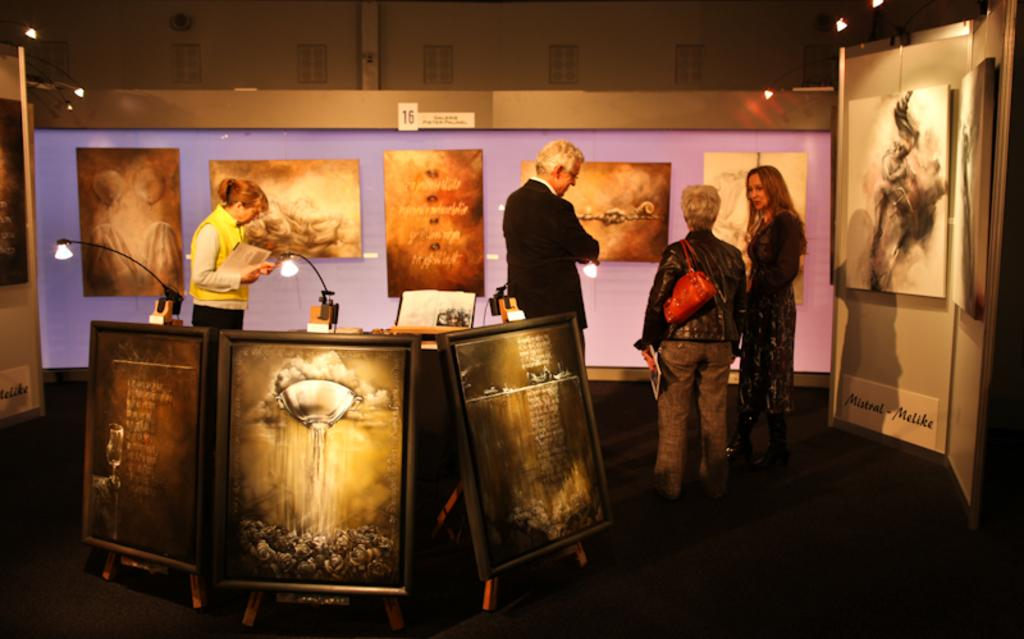How many people are present in the image? There are four people standing in the image. What surface are the people standing on? The people are standing on the floor. What can be seen in the image besides the people? There is a bag, boards, walls, lights, some objects, and windows visible in the image. What type of doctor is present in the image? There is no doctor present in the image. What authority figure can be seen in the image? There is no authority figure present in the image. 